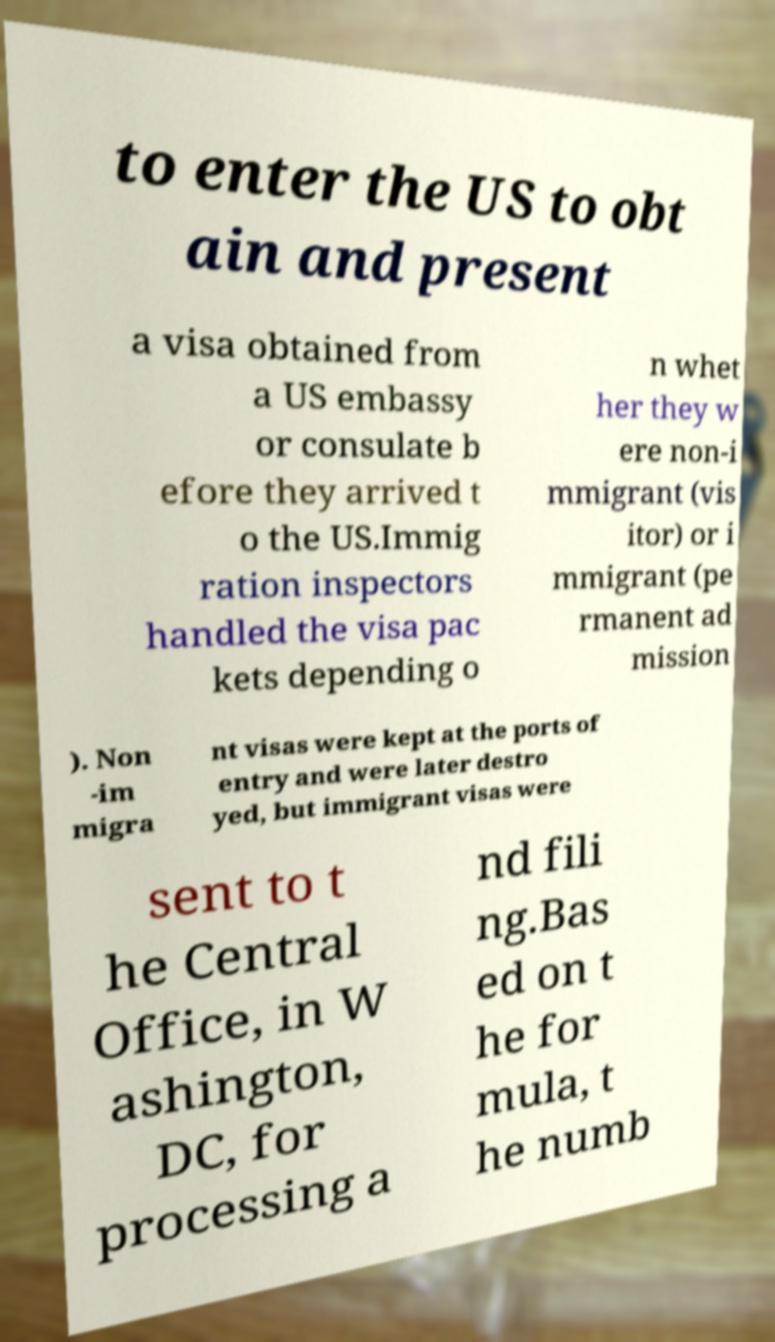Please identify and transcribe the text found in this image. to enter the US to obt ain and present a visa obtained from a US embassy or consulate b efore they arrived t o the US.Immig ration inspectors handled the visa pac kets depending o n whet her they w ere non-i mmigrant (vis itor) or i mmigrant (pe rmanent ad mission ). Non -im migra nt visas were kept at the ports of entry and were later destro yed, but immigrant visas were sent to t he Central Office, in W ashington, DC, for processing a nd fili ng.Bas ed on t he for mula, t he numb 